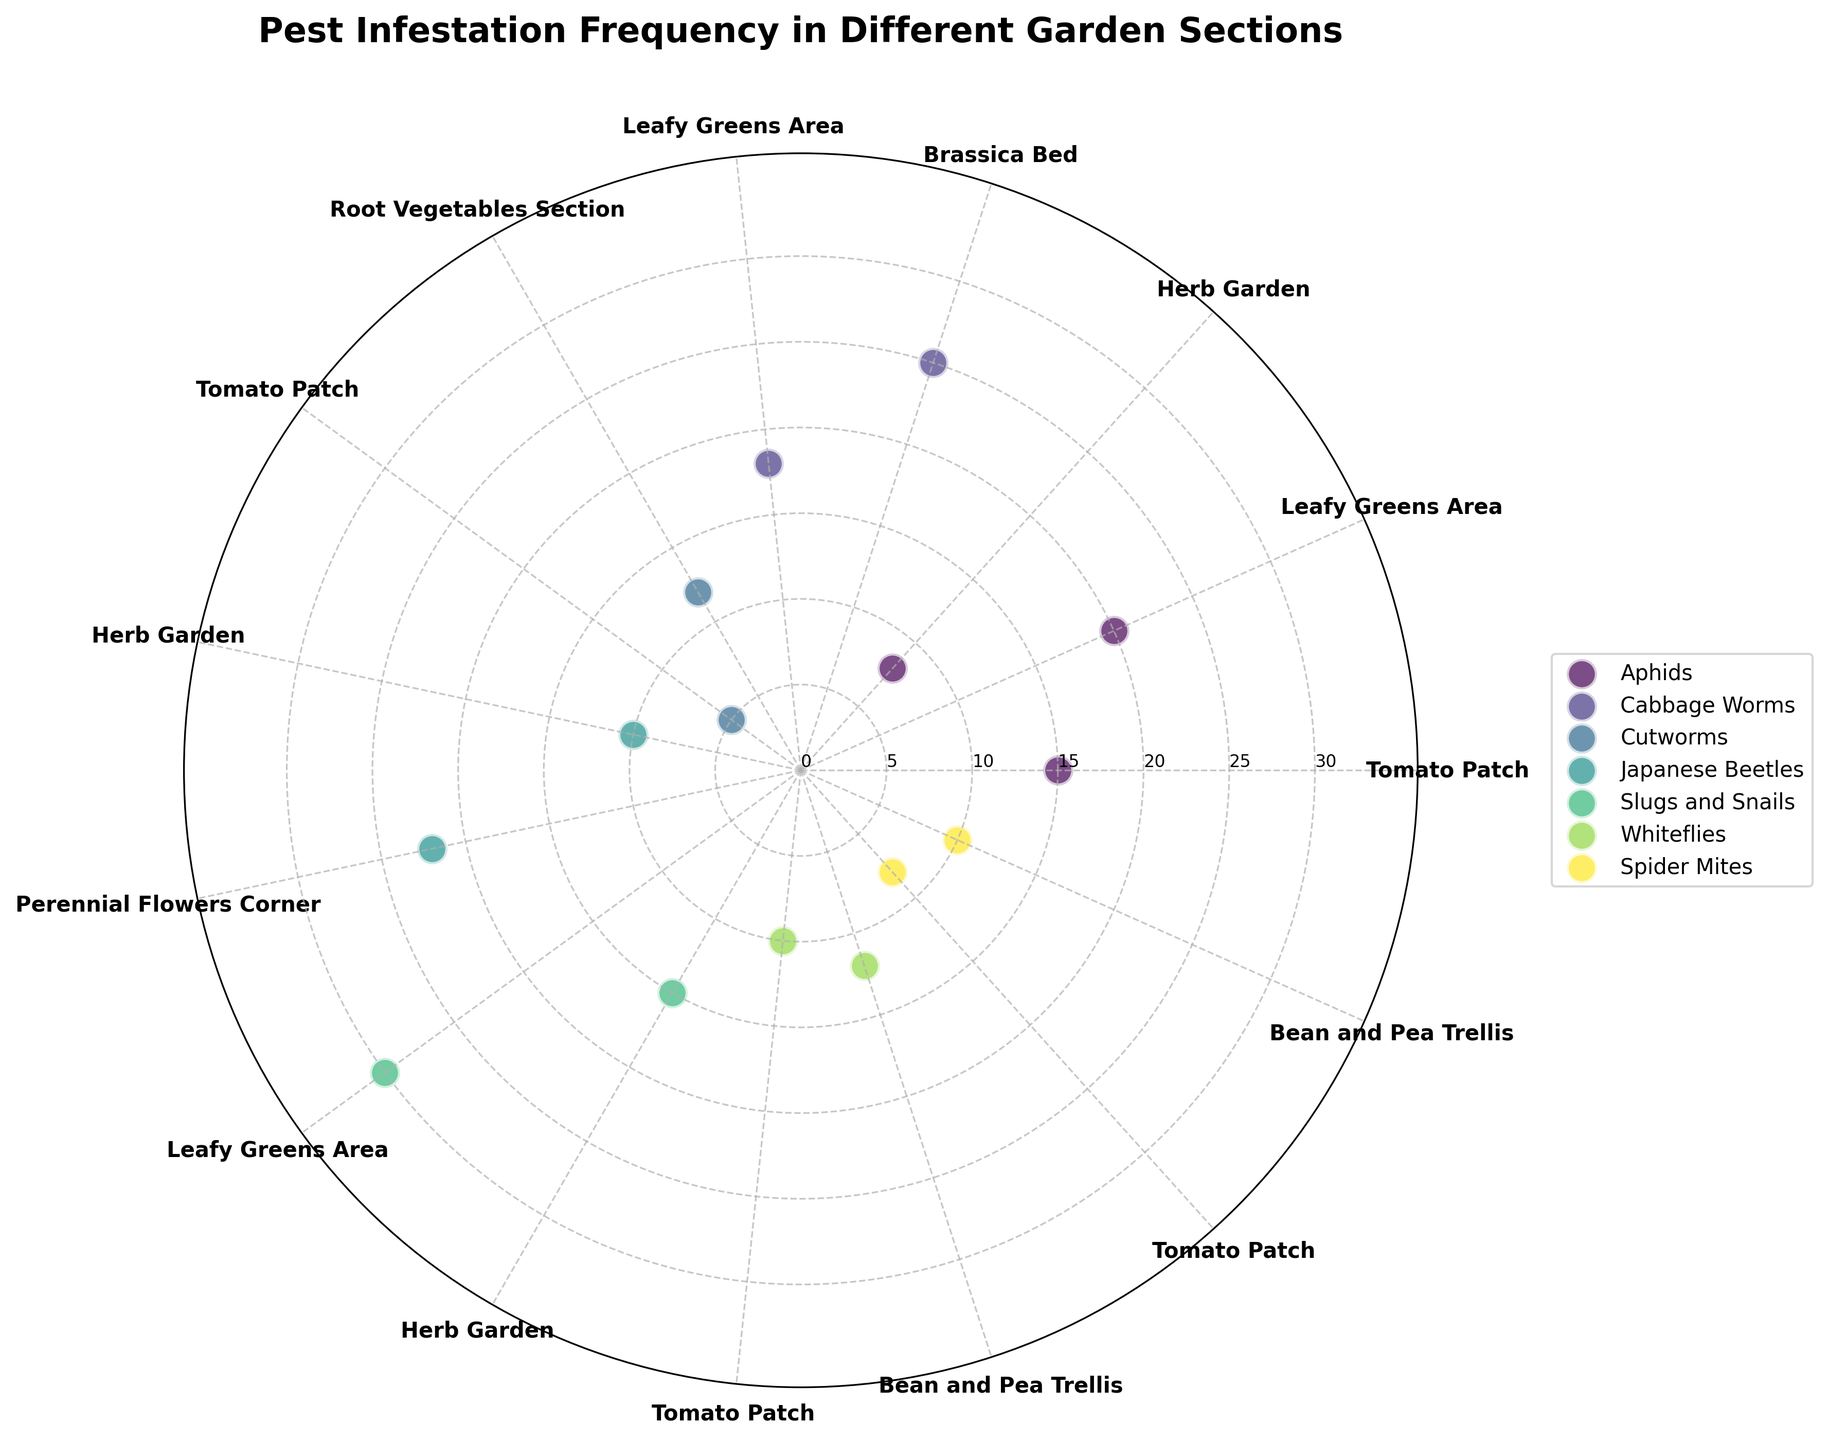What's the title of the figure? The title of the chart is usually located at the top of the figure. It describes what the figure is about.
Answer: Pest Infestation Frequency in Different Garden Sections Which section of the garden has the highest frequency of slugs and snails? To find this, locate the data points that represent slugs and snails. The highest radial distance among these points indicates the highest frequency.
Answer: Leafy Greens Area How many types of pests are included in the figure? The unique colors used in the scatter plot each represent a different type of pest. By counting those unique colors, you can determine the number of pest types.
Answer: 6 Which section of the garden is most frequently affected by aphids? Identify the sections where aphids appear. The one with the highest radial distance corresponding to aphids indicates the section most affected.
Answer: Leafy Greens Area What's the frequency difference of cutworms between the Root Vegetables Section and the Tomato Patch? Locate the cutworms data points for both the Root Vegetables Section and the Tomato Patch, then subtract the Tomato Patch frequency from the Root Vegetables Section frequency.
Answer: 7 Which pests are found in the Herb Garden and what are their frequencies? Identify all the data points corresponding to the Herb Garden and list the pests and their respective frequencies.
Answer: Aphids: 8, Japanese Beetles: 10, Slugs and Snails: 15 Which garden section shows the highest overall pest infestation frequency? Sum the frequencies of all the pest types for each section. The section with the highest total frequency is the answer.
Answer: Leafy Greens Area Which pest type is not found in the Tomato Patch? List all pest types and check which ones are plotted in the Tomato Patch. The one that isn't plotted there is not found in the Tomato Patch.
Answer: Cabbage Worms Compare the frequencies of spider mites and whiteflies in the Bean and Pea Trellis section and state which one is higher. Find the data points of spider mites and whiteflies in the Bean and Pea Trellis section and compare their radial distances.
Answer: Whiteflies are higher What's the average pest infestation frequency in the Leafy Greens Area? Sum the frequencies of all pests in the Leafy Greens Area and divide by the number of pest types present in that section.
Answer: 17 